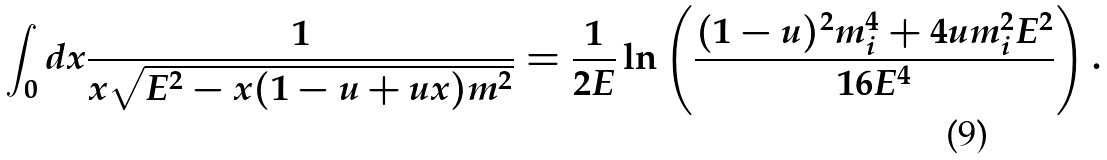Convert formula to latex. <formula><loc_0><loc_0><loc_500><loc_500>\int _ { 0 } d x \frac { 1 } { x \sqrt { E ^ { 2 } - x ( 1 - u + u x ) m ^ { 2 } } } = \frac { 1 } { 2 E } \ln \left ( \frac { ( 1 - u ) ^ { 2 } m _ { i } ^ { 4 } + 4 u m _ { i } ^ { 2 } E ^ { 2 } } { 1 6 E ^ { 4 } } \right ) .</formula> 